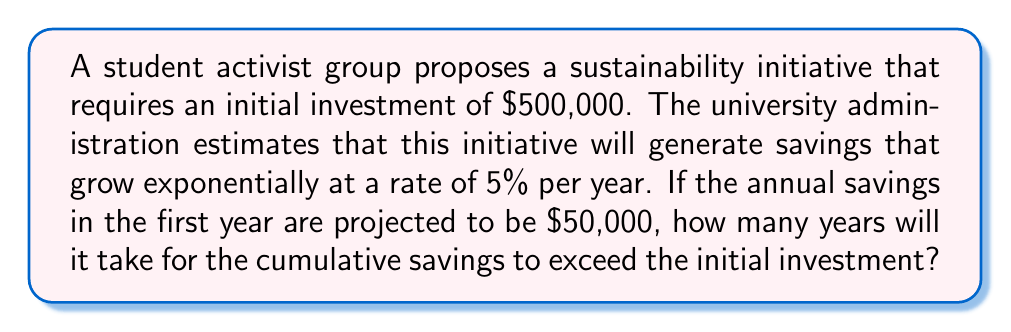What is the answer to this math problem? To solve this problem, we need to use an exponential function to model the growth of savings over time and then find the point at which the cumulative savings surpass the initial investment.

Let's define our variables:
$t$ = number of years
$S(t)$ = savings in year $t$
$C(t)$ = cumulative savings up to year $t$

1) The savings for each year can be modeled by the exponential function:
   $S(t) = 50000 \cdot (1.05)^{t-1}$

2) The cumulative savings can be expressed as the sum of a geometric series:
   $C(t) = 50000 \cdot \frac{(1.05)^t - 1}{0.05}$

3) We need to find $t$ where $C(t)$ exceeds $500,000:
   $500000 < 50000 \cdot \frac{(1.05)^t - 1}{0.05}$

4) Solving this inequality:
   $10 < \frac{(1.05)^t - 1}{0.05}$
   $0.5 < (1.05)^t - 1$
   $1.5 < (1.05)^t$
   $\ln(1.5) < t \cdot \ln(1.05)$
   $t > \frac{\ln(1.5)}{\ln(1.05)} \approx 8.31$

5) Since $t$ must be a whole number of years, we round up to the next integer.
Answer: It will take 9 years for the cumulative savings to exceed the initial investment. 